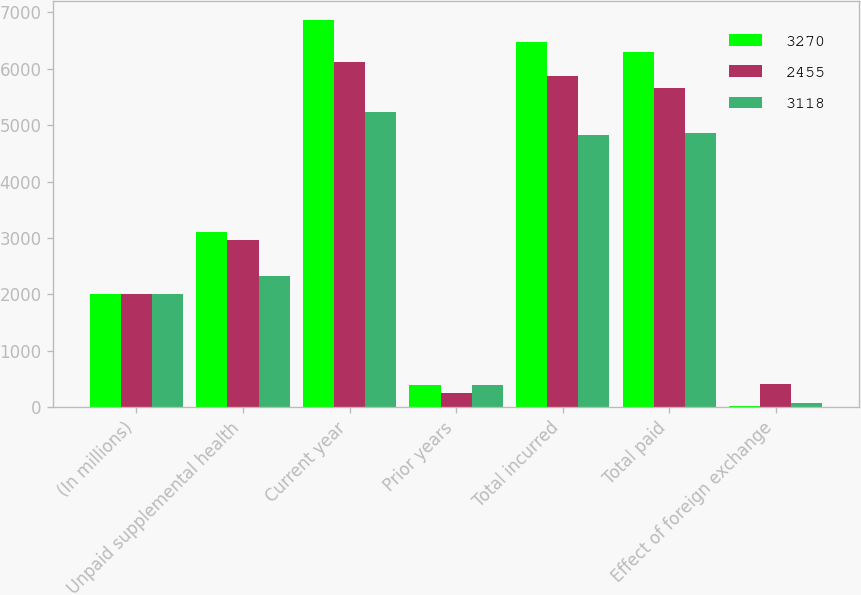<chart> <loc_0><loc_0><loc_500><loc_500><stacked_bar_chart><ecel><fcel>(In millions)<fcel>Unpaid supplemental health<fcel>Current year<fcel>Prior years<fcel>Total incurred<fcel>Total paid<fcel>Effect of foreign exchange<nl><fcel>3270<fcel>2009<fcel>3105<fcel>6864<fcel>398<fcel>6466<fcel>6301<fcel>19<nl><fcel>2455<fcel>2008<fcel>2959<fcel>6127<fcel>253<fcel>5874<fcel>5653<fcel>406<nl><fcel>3118<fcel>2007<fcel>2332<fcel>5225<fcel>401<fcel>4824<fcel>4857<fcel>72<nl></chart> 